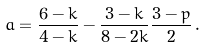Convert formula to latex. <formula><loc_0><loc_0><loc_500><loc_500>a = \frac { 6 - k } { 4 - k } - \frac { 3 - k } { 8 - 2 k } \frac { 3 - p } { 2 } \, .</formula> 